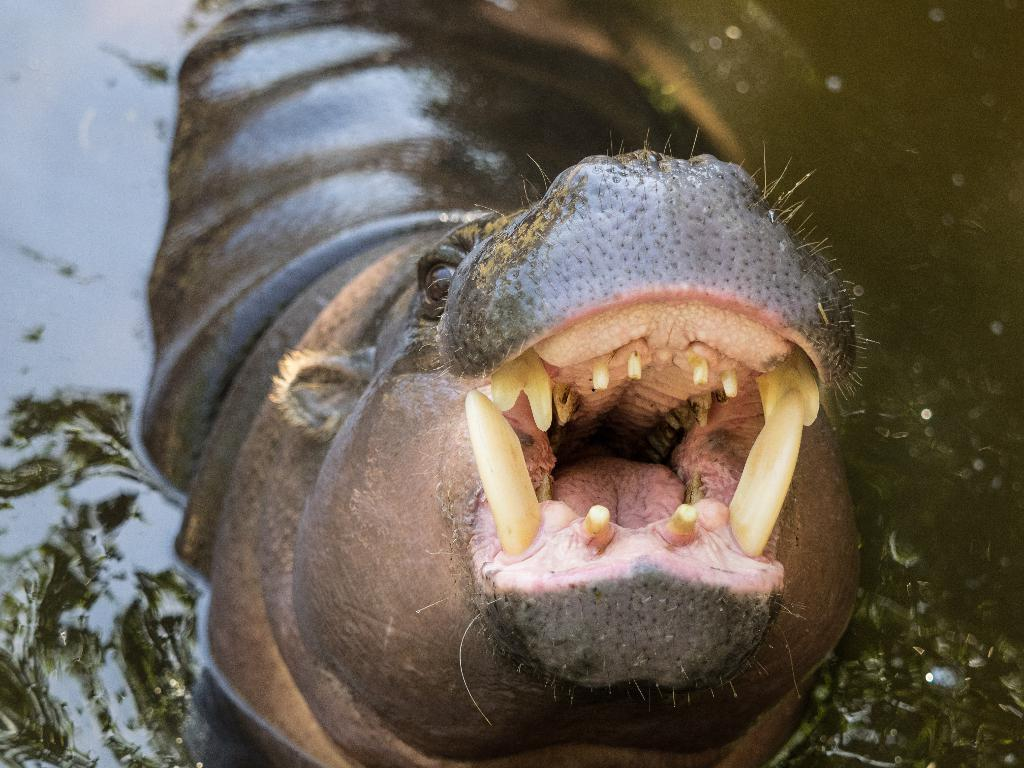What is the main subject of the image? There is an animal in the water in the image. Can you describe the animal's location in the image? The animal is in the water. What type of environment is depicted in the image? The image shows a water environment. Who is the creator of the plantation shown in the image? There is no plantation present in the image; it features an animal in the water. 